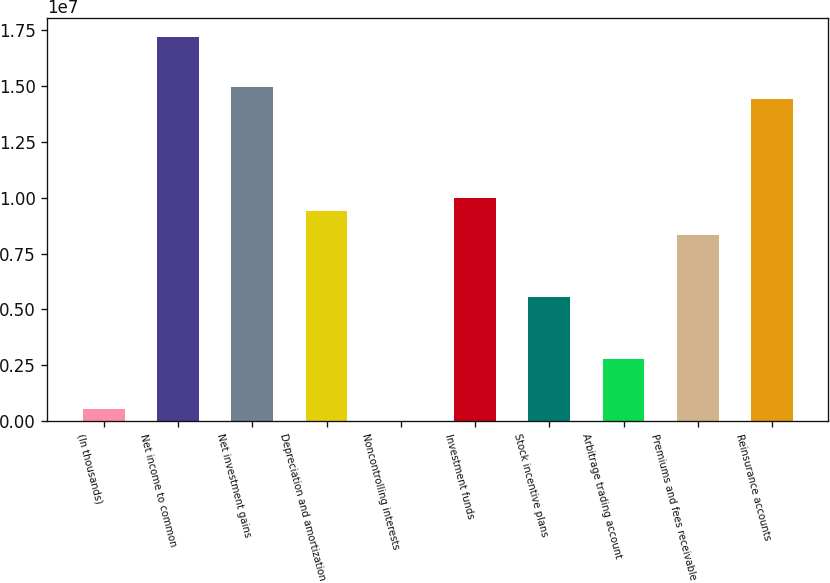Convert chart. <chart><loc_0><loc_0><loc_500><loc_500><bar_chart><fcel>(In thousands)<fcel>Net income to common<fcel>Net investment gains<fcel>Depreciation and amortization<fcel>Noncontrolling interests<fcel>Investment funds<fcel>Stock incentive plans<fcel>Arbitrage trading account<fcel>Premiums and fees receivable<fcel>Reinsurance accounts<nl><fcel>555532<fcel>1.71744e+07<fcel>1.49586e+07<fcel>9.41895e+06<fcel>1569<fcel>9.97291e+06<fcel>5.5412e+06<fcel>2.77139e+06<fcel>8.31102e+06<fcel>1.44046e+07<nl></chart> 